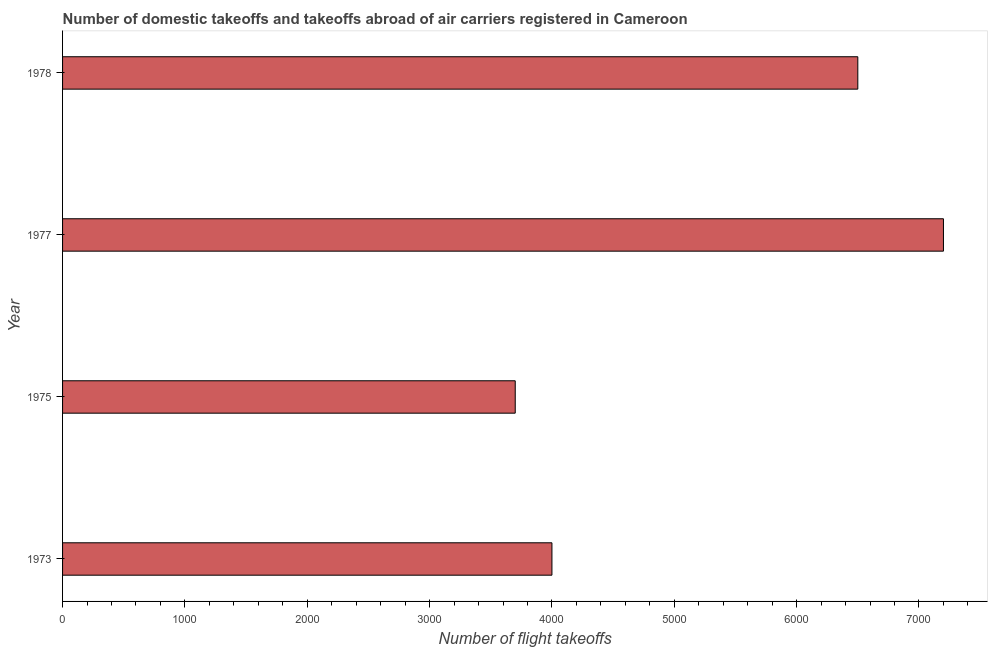What is the title of the graph?
Your answer should be very brief. Number of domestic takeoffs and takeoffs abroad of air carriers registered in Cameroon. What is the label or title of the X-axis?
Offer a very short reply. Number of flight takeoffs. What is the number of flight takeoffs in 1977?
Provide a succinct answer. 7200. Across all years, what is the maximum number of flight takeoffs?
Offer a terse response. 7200. Across all years, what is the minimum number of flight takeoffs?
Offer a very short reply. 3700. In which year was the number of flight takeoffs minimum?
Make the answer very short. 1975. What is the sum of the number of flight takeoffs?
Ensure brevity in your answer.  2.14e+04. What is the difference between the number of flight takeoffs in 1975 and 1978?
Offer a terse response. -2800. What is the average number of flight takeoffs per year?
Offer a very short reply. 5350. What is the median number of flight takeoffs?
Make the answer very short. 5250. In how many years, is the number of flight takeoffs greater than 6400 ?
Offer a very short reply. 2. Do a majority of the years between 1977 and 1978 (inclusive) have number of flight takeoffs greater than 400 ?
Make the answer very short. Yes. What is the ratio of the number of flight takeoffs in 1975 to that in 1977?
Provide a short and direct response. 0.51. Is the difference between the number of flight takeoffs in 1975 and 1977 greater than the difference between any two years?
Ensure brevity in your answer.  Yes. What is the difference between the highest and the second highest number of flight takeoffs?
Your answer should be very brief. 700. What is the difference between the highest and the lowest number of flight takeoffs?
Offer a very short reply. 3500. Are all the bars in the graph horizontal?
Your answer should be very brief. Yes. How many years are there in the graph?
Your answer should be compact. 4. What is the difference between two consecutive major ticks on the X-axis?
Keep it short and to the point. 1000. What is the Number of flight takeoffs of 1973?
Your answer should be very brief. 4000. What is the Number of flight takeoffs of 1975?
Provide a short and direct response. 3700. What is the Number of flight takeoffs in 1977?
Offer a very short reply. 7200. What is the Number of flight takeoffs of 1978?
Give a very brief answer. 6500. What is the difference between the Number of flight takeoffs in 1973 and 1975?
Offer a terse response. 300. What is the difference between the Number of flight takeoffs in 1973 and 1977?
Keep it short and to the point. -3200. What is the difference between the Number of flight takeoffs in 1973 and 1978?
Your response must be concise. -2500. What is the difference between the Number of flight takeoffs in 1975 and 1977?
Provide a short and direct response. -3500. What is the difference between the Number of flight takeoffs in 1975 and 1978?
Provide a short and direct response. -2800. What is the difference between the Number of flight takeoffs in 1977 and 1978?
Ensure brevity in your answer.  700. What is the ratio of the Number of flight takeoffs in 1973 to that in 1975?
Offer a very short reply. 1.08. What is the ratio of the Number of flight takeoffs in 1973 to that in 1977?
Give a very brief answer. 0.56. What is the ratio of the Number of flight takeoffs in 1973 to that in 1978?
Your answer should be very brief. 0.61. What is the ratio of the Number of flight takeoffs in 1975 to that in 1977?
Provide a succinct answer. 0.51. What is the ratio of the Number of flight takeoffs in 1975 to that in 1978?
Ensure brevity in your answer.  0.57. What is the ratio of the Number of flight takeoffs in 1977 to that in 1978?
Make the answer very short. 1.11. 